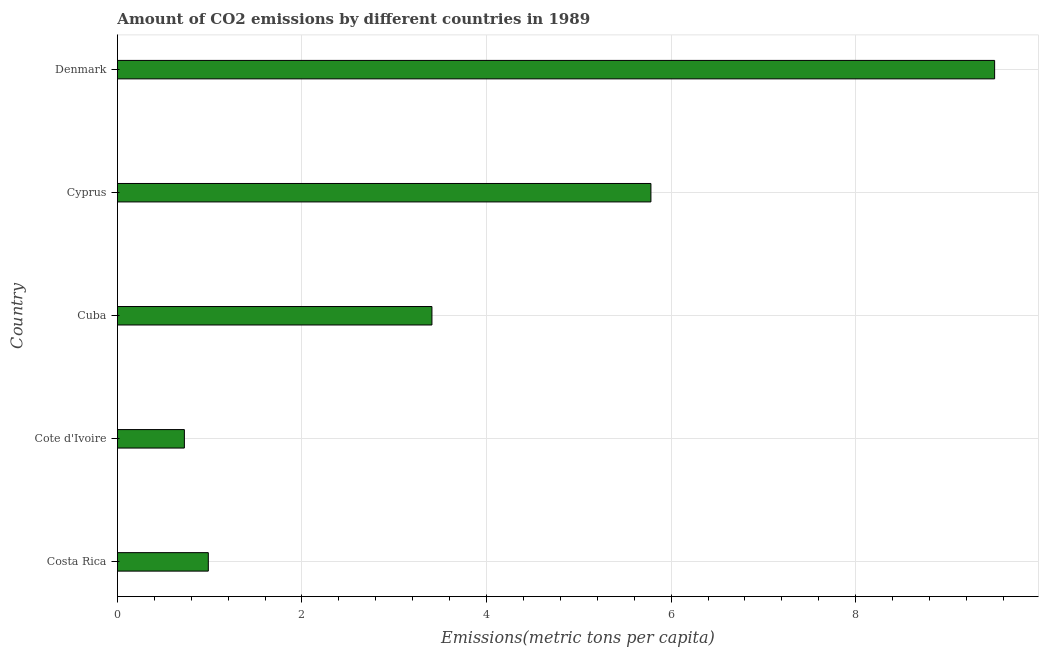Does the graph contain any zero values?
Your answer should be very brief. No. Does the graph contain grids?
Your answer should be compact. Yes. What is the title of the graph?
Offer a terse response. Amount of CO2 emissions by different countries in 1989. What is the label or title of the X-axis?
Offer a very short reply. Emissions(metric tons per capita). What is the label or title of the Y-axis?
Provide a succinct answer. Country. What is the amount of co2 emissions in Cyprus?
Ensure brevity in your answer.  5.78. Across all countries, what is the maximum amount of co2 emissions?
Provide a short and direct response. 9.51. Across all countries, what is the minimum amount of co2 emissions?
Your response must be concise. 0.73. In which country was the amount of co2 emissions maximum?
Provide a short and direct response. Denmark. In which country was the amount of co2 emissions minimum?
Give a very brief answer. Cote d'Ivoire. What is the sum of the amount of co2 emissions?
Your response must be concise. 20.4. What is the difference between the amount of co2 emissions in Cuba and Denmark?
Make the answer very short. -6.1. What is the average amount of co2 emissions per country?
Give a very brief answer. 4.08. What is the median amount of co2 emissions?
Offer a very short reply. 3.41. In how many countries, is the amount of co2 emissions greater than 8.8 metric tons per capita?
Keep it short and to the point. 1. What is the ratio of the amount of co2 emissions in Cote d'Ivoire to that in Cyprus?
Offer a very short reply. 0.13. Is the difference between the amount of co2 emissions in Costa Rica and Cyprus greater than the difference between any two countries?
Ensure brevity in your answer.  No. What is the difference between the highest and the second highest amount of co2 emissions?
Give a very brief answer. 3.72. What is the difference between the highest and the lowest amount of co2 emissions?
Offer a terse response. 8.78. In how many countries, is the amount of co2 emissions greater than the average amount of co2 emissions taken over all countries?
Make the answer very short. 2. Are all the bars in the graph horizontal?
Provide a short and direct response. Yes. How many countries are there in the graph?
Give a very brief answer. 5. What is the difference between two consecutive major ticks on the X-axis?
Keep it short and to the point. 2. Are the values on the major ticks of X-axis written in scientific E-notation?
Provide a short and direct response. No. What is the Emissions(metric tons per capita) of Costa Rica?
Offer a very short reply. 0.99. What is the Emissions(metric tons per capita) of Cote d'Ivoire?
Offer a very short reply. 0.73. What is the Emissions(metric tons per capita) in Cuba?
Your answer should be very brief. 3.41. What is the Emissions(metric tons per capita) in Cyprus?
Provide a short and direct response. 5.78. What is the Emissions(metric tons per capita) in Denmark?
Provide a succinct answer. 9.51. What is the difference between the Emissions(metric tons per capita) in Costa Rica and Cote d'Ivoire?
Offer a very short reply. 0.26. What is the difference between the Emissions(metric tons per capita) in Costa Rica and Cuba?
Your answer should be compact. -2.42. What is the difference between the Emissions(metric tons per capita) in Costa Rica and Cyprus?
Offer a terse response. -4.8. What is the difference between the Emissions(metric tons per capita) in Costa Rica and Denmark?
Provide a short and direct response. -8.52. What is the difference between the Emissions(metric tons per capita) in Cote d'Ivoire and Cuba?
Offer a terse response. -2.68. What is the difference between the Emissions(metric tons per capita) in Cote d'Ivoire and Cyprus?
Your answer should be very brief. -5.06. What is the difference between the Emissions(metric tons per capita) in Cote d'Ivoire and Denmark?
Provide a succinct answer. -8.78. What is the difference between the Emissions(metric tons per capita) in Cuba and Cyprus?
Offer a terse response. -2.37. What is the difference between the Emissions(metric tons per capita) in Cuba and Denmark?
Your response must be concise. -6.1. What is the difference between the Emissions(metric tons per capita) in Cyprus and Denmark?
Your answer should be compact. -3.72. What is the ratio of the Emissions(metric tons per capita) in Costa Rica to that in Cote d'Ivoire?
Provide a short and direct response. 1.36. What is the ratio of the Emissions(metric tons per capita) in Costa Rica to that in Cuba?
Provide a short and direct response. 0.29. What is the ratio of the Emissions(metric tons per capita) in Costa Rica to that in Cyprus?
Give a very brief answer. 0.17. What is the ratio of the Emissions(metric tons per capita) in Costa Rica to that in Denmark?
Provide a short and direct response. 0.1. What is the ratio of the Emissions(metric tons per capita) in Cote d'Ivoire to that in Cuba?
Provide a short and direct response. 0.21. What is the ratio of the Emissions(metric tons per capita) in Cote d'Ivoire to that in Cyprus?
Your answer should be very brief. 0.13. What is the ratio of the Emissions(metric tons per capita) in Cote d'Ivoire to that in Denmark?
Make the answer very short. 0.08. What is the ratio of the Emissions(metric tons per capita) in Cuba to that in Cyprus?
Offer a terse response. 0.59. What is the ratio of the Emissions(metric tons per capita) in Cuba to that in Denmark?
Offer a very short reply. 0.36. What is the ratio of the Emissions(metric tons per capita) in Cyprus to that in Denmark?
Make the answer very short. 0.61. 